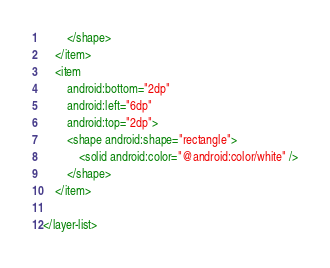<code> <loc_0><loc_0><loc_500><loc_500><_XML_>        </shape>
    </item>
    <item
        android:bottom="2dp"
        android:left="6dp"
        android:top="2dp">
        <shape android:shape="rectangle">
            <solid android:color="@android:color/white" />
        </shape>
    </item>

</layer-list></code> 